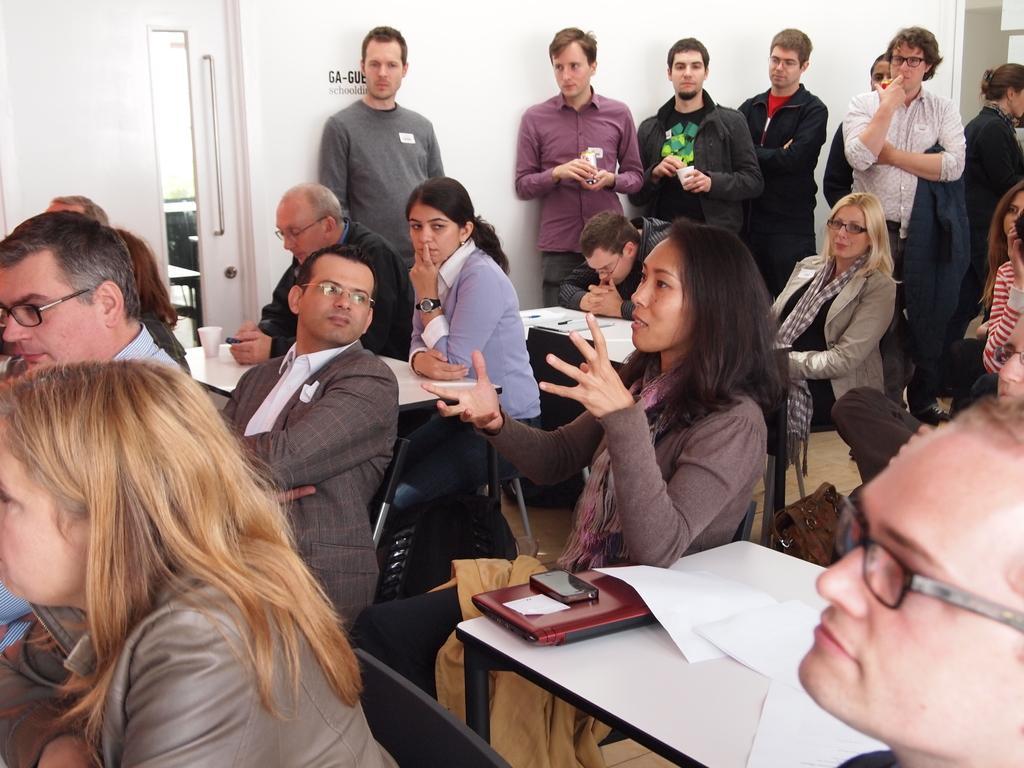How would you summarize this image in a sentence or two? In the picture I can see people among them some are standing and some are sitting in front of tables. On tables I can see some objects. In the background I can see a white color wall which has something written on it. 